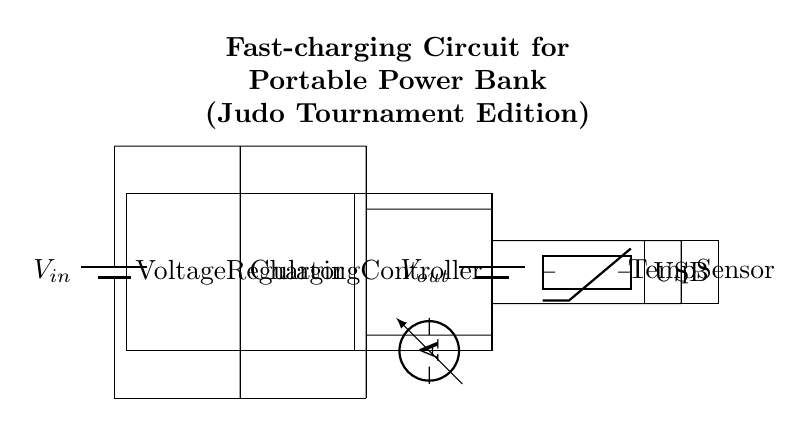What is the type of power source used? The circuit uses a battery as the power source, which is indicated by the symbol labeled as "V_in."
Answer: Battery What component regulates the voltage? The circuit has a voltage regulator represented by a rectangular box, which is responsible for maintaining a steady output voltage.
Answer: Voltage regulator Which component controls the charging process? The charging controller is depicted as a second rectangular box, and its function is to manage the charging of the power bank's battery.
Answer: Charging controller Which type of output port is used in this circuit? The circuit diagram shows a USB port labeled clearly as "USB," indicating that it allows for USB connectivity for power output.
Answer: USB What additional sensor is included for safety? The circuit includes a temperature sensor indicated by the thermistor symbol, which ensures safe operation by monitoring temperature.
Answer: Temperature sensor What is indicated by the ammeter in the circuit? The ammeter measures the current flowing in the circuit, which is shown between the charging controller and the power bank battery.
Answer: Current How does this circuit benefit judo tournaments? This circuit setup allows for fast charging of portable devices, which is crucial for maintaining power during extended judo tournament events.
Answer: Fast charging 